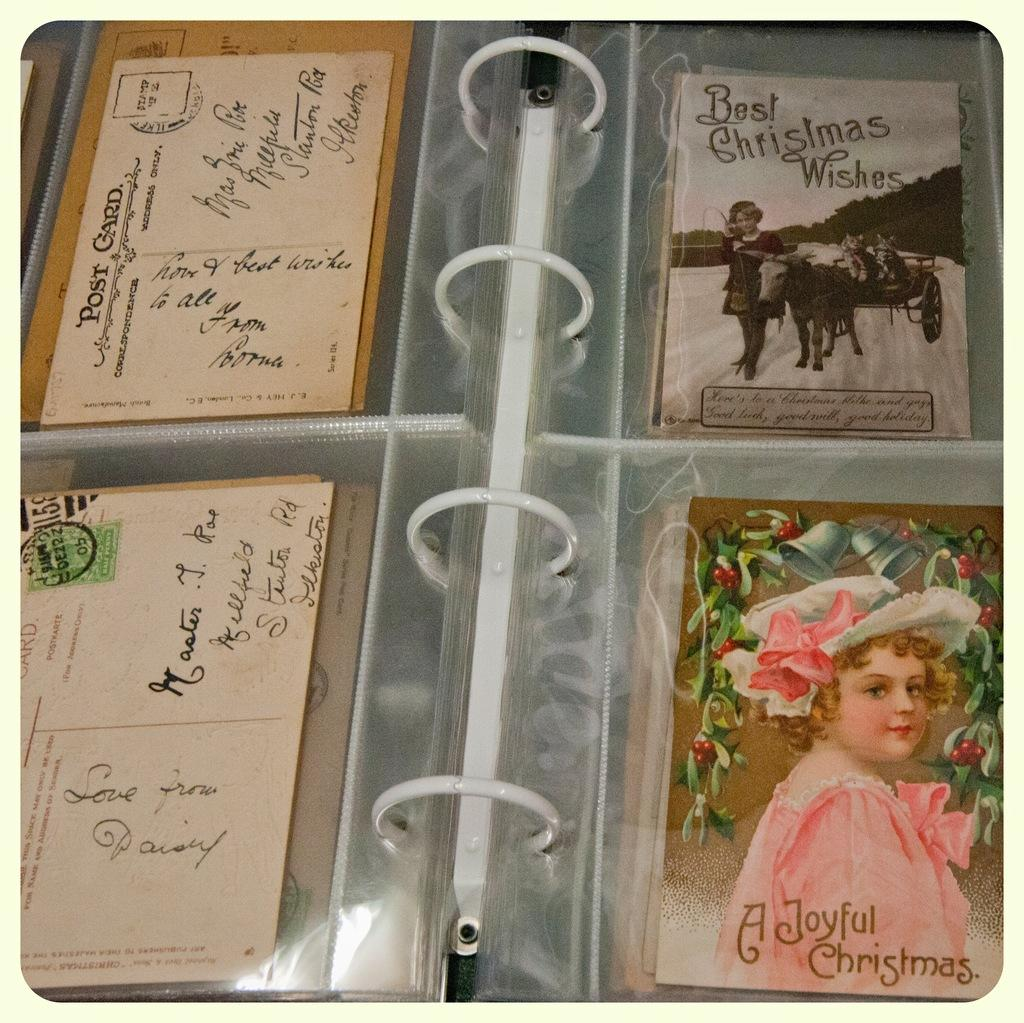What types of cards are visible in the image? There are postcards and greeting cards in the image. Where are the postcards and greeting cards located? The postcards and greeting cards are in a photo album. What type of juice can be seen being poured from a bottle in the image? There is no juice or bottle present in the image; it only features postcards and greeting cards in a photo album. 